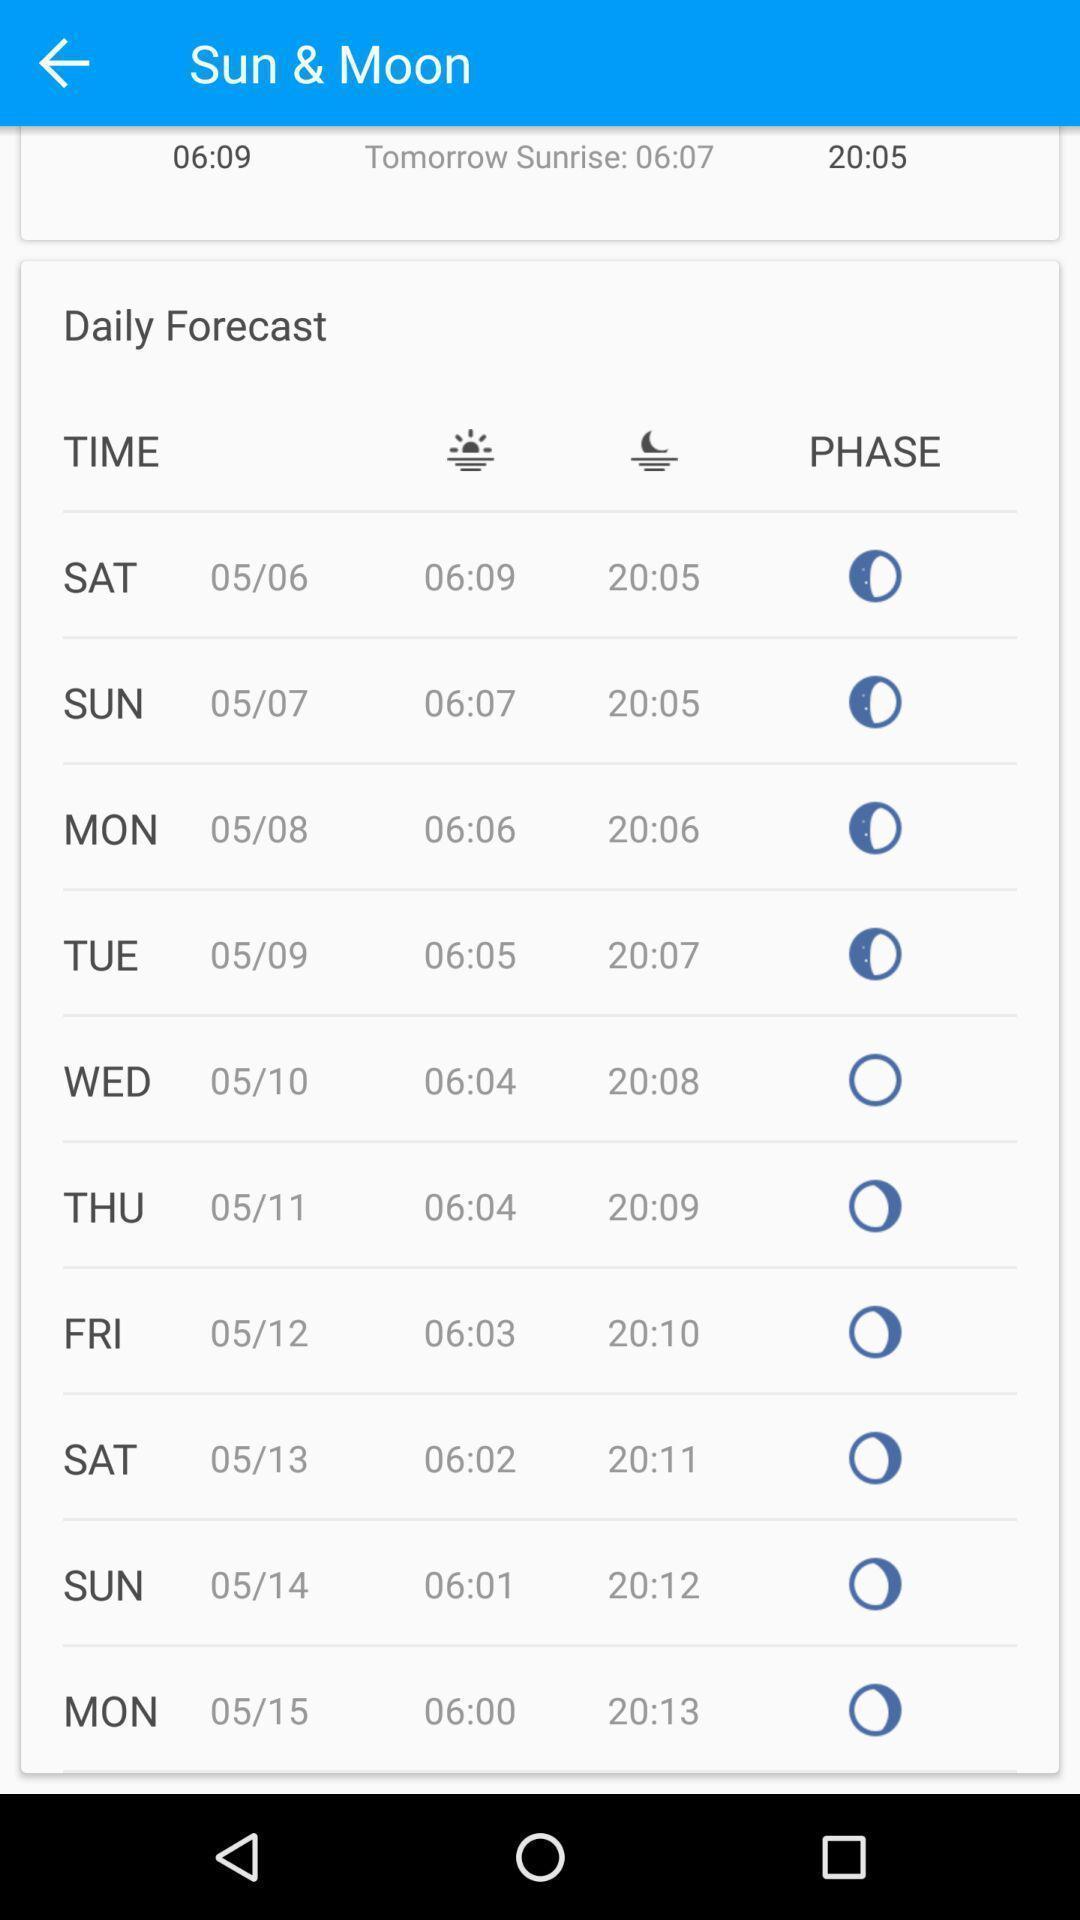Tell me about the visual elements in this screen capture. Screen shows sun moon daily details. 